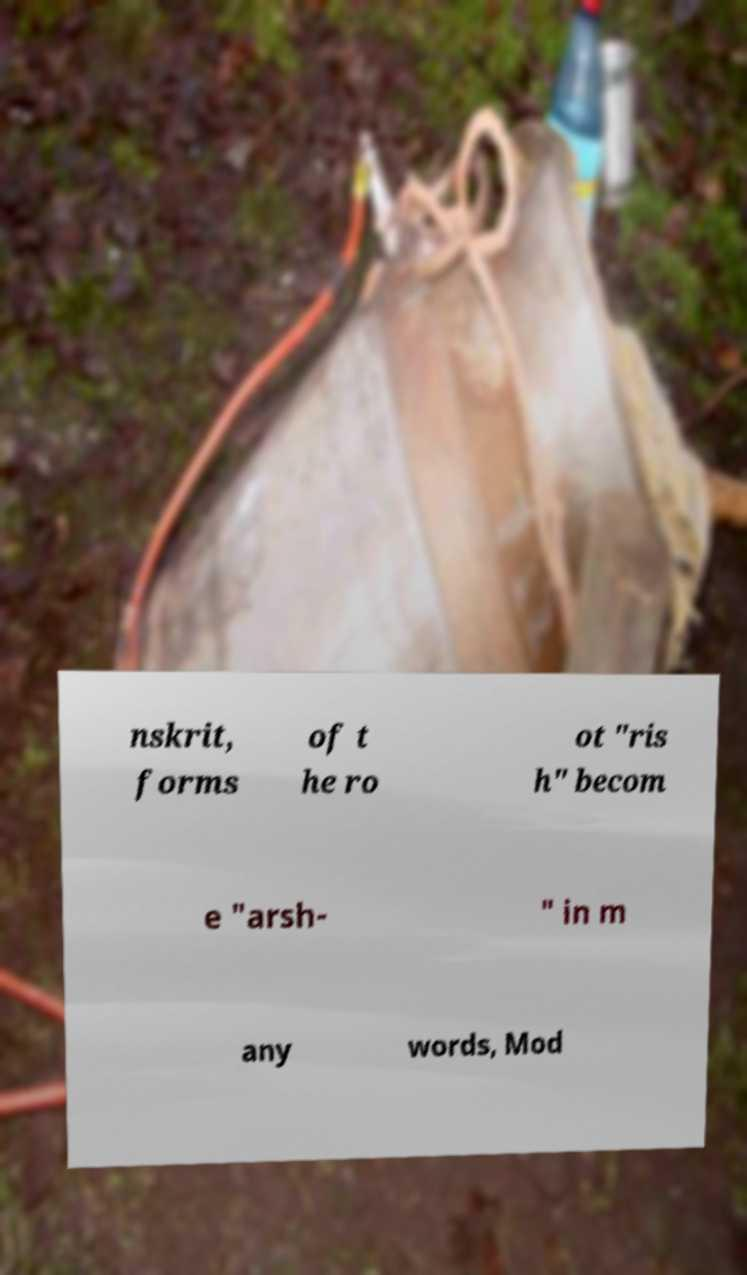Can you accurately transcribe the text from the provided image for me? nskrit, forms of t he ro ot "ris h" becom e "arsh- " in m any words, Mod 